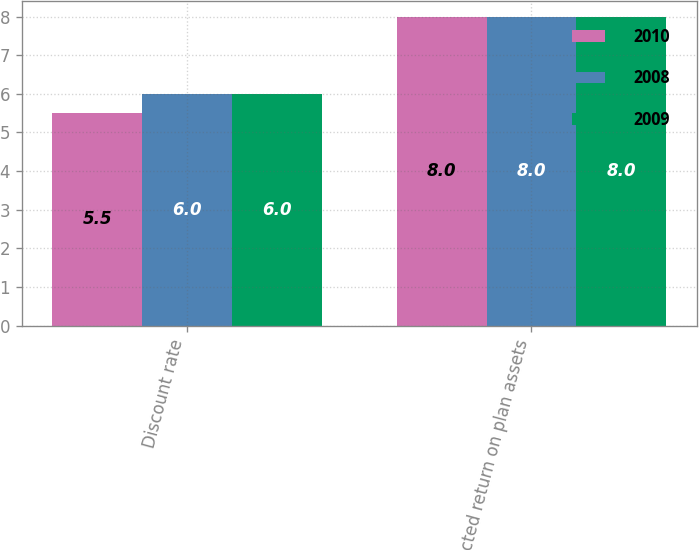Convert chart. <chart><loc_0><loc_0><loc_500><loc_500><stacked_bar_chart><ecel><fcel>Discount rate<fcel>Expected return on plan assets<nl><fcel>2010<fcel>5.5<fcel>8<nl><fcel>2008<fcel>6<fcel>8<nl><fcel>2009<fcel>6<fcel>8<nl></chart> 